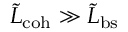Convert formula to latex. <formula><loc_0><loc_0><loc_500><loc_500>\tilde { L } _ { c o h } \gg \tilde { L } _ { b s }</formula> 